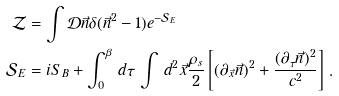Convert formula to latex. <formula><loc_0><loc_0><loc_500><loc_500>\mathcal { Z } & = \int \mathcal { D } \vec { n } \delta ( \vec { n } ^ { 2 } - 1 ) e ^ { - \mathcal { S } _ { E } } \\ \mathcal { S } _ { E } & = i S _ { B } + \int _ { 0 } ^ { \beta } \, d \tau \, \int \, d ^ { 2 } \vec { x } \frac { \rho _ { s } } { 2 } \left [ ( \partial _ { \vec { x } } \vec { n } ) ^ { 2 } + \frac { ( \partial _ { \tau } \vec { n } ) ^ { 2 } } { c ^ { 2 } } \right ] \, .</formula> 